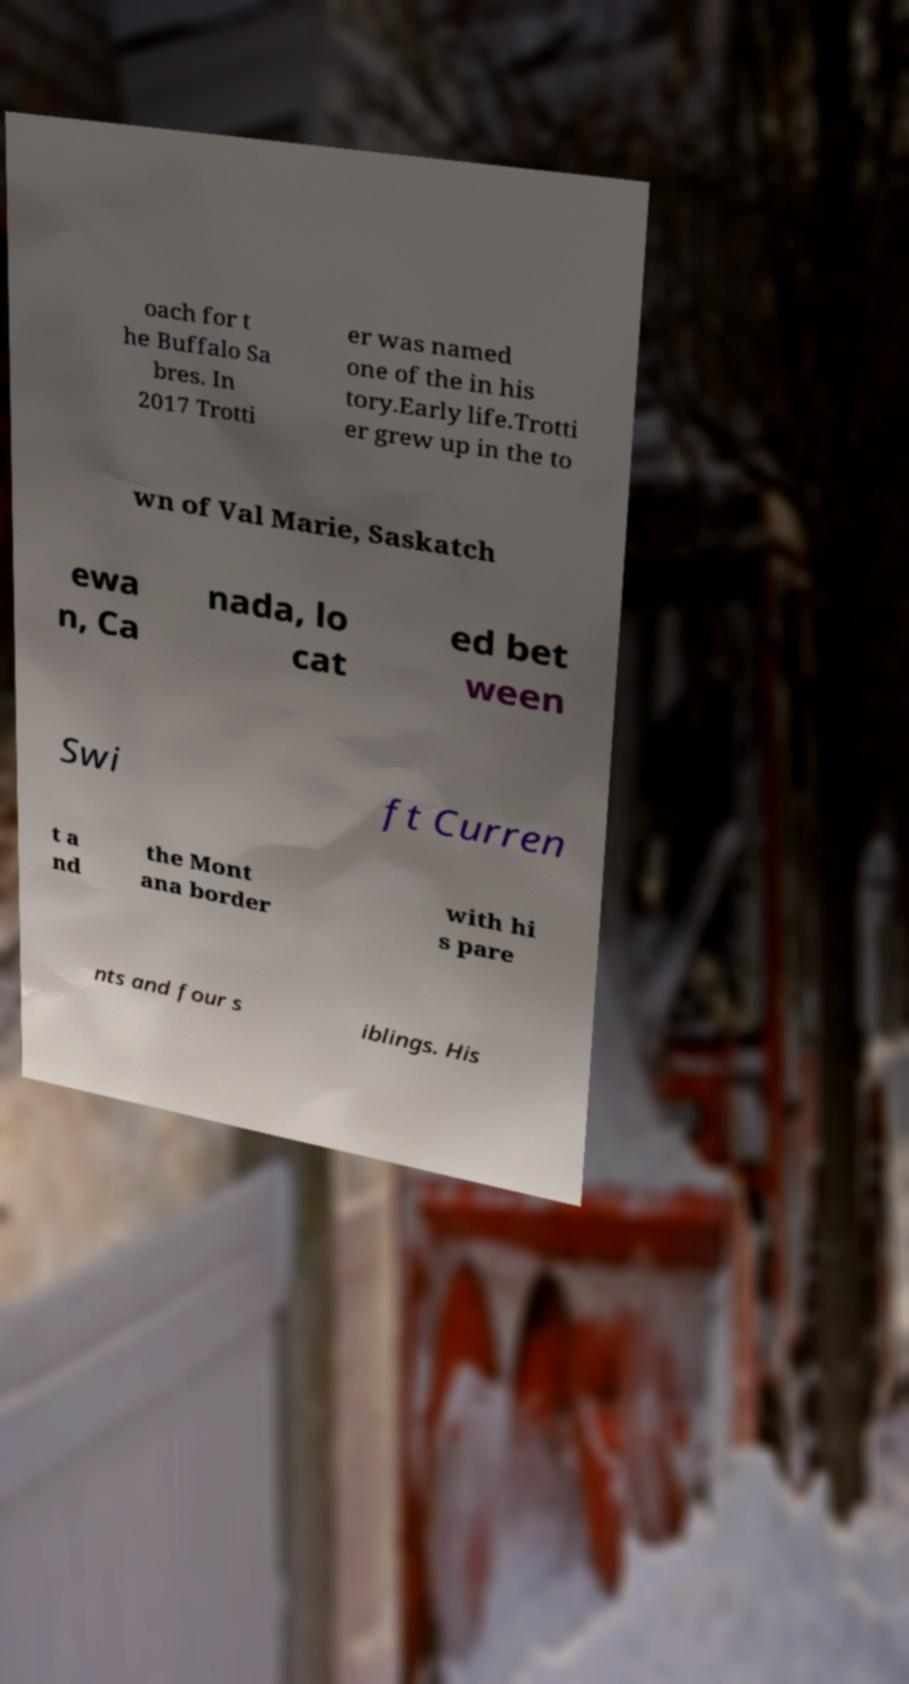For documentation purposes, I need the text within this image transcribed. Could you provide that? oach for t he Buffalo Sa bres. In 2017 Trotti er was named one of the in his tory.Early life.Trotti er grew up in the to wn of Val Marie, Saskatch ewa n, Ca nada, lo cat ed bet ween Swi ft Curren t a nd the Mont ana border with hi s pare nts and four s iblings. His 